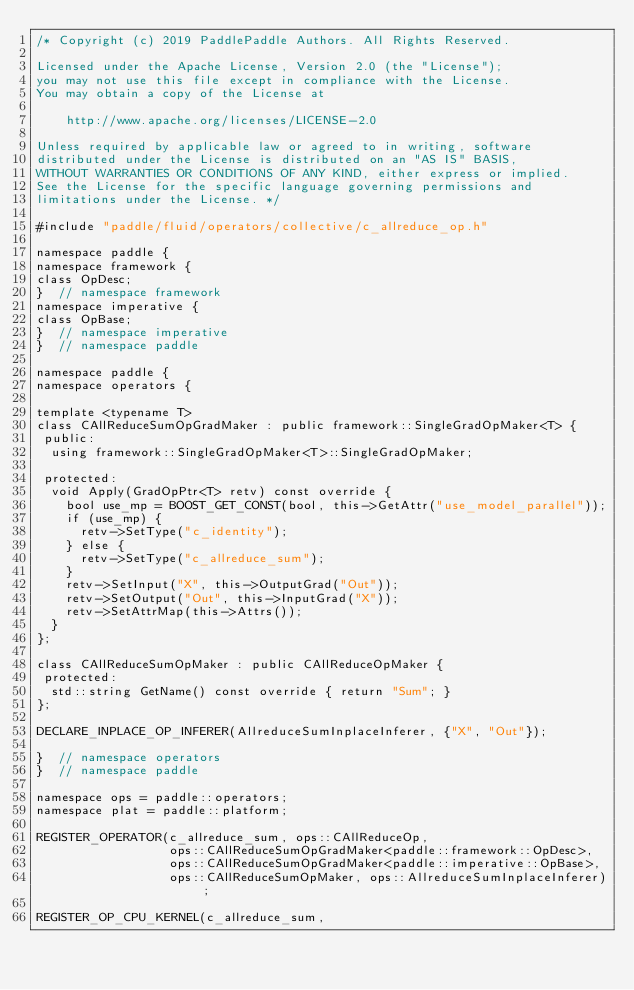<code> <loc_0><loc_0><loc_500><loc_500><_C++_>/* Copyright (c) 2019 PaddlePaddle Authors. All Rights Reserved.

Licensed under the Apache License, Version 2.0 (the "License");
you may not use this file except in compliance with the License.
You may obtain a copy of the License at

    http://www.apache.org/licenses/LICENSE-2.0

Unless required by applicable law or agreed to in writing, software
distributed under the License is distributed on an "AS IS" BASIS,
WITHOUT WARRANTIES OR CONDITIONS OF ANY KIND, either express or implied.
See the License for the specific language governing permissions and
limitations under the License. */

#include "paddle/fluid/operators/collective/c_allreduce_op.h"

namespace paddle {
namespace framework {
class OpDesc;
}  // namespace framework
namespace imperative {
class OpBase;
}  // namespace imperative
}  // namespace paddle

namespace paddle {
namespace operators {

template <typename T>
class CAllReduceSumOpGradMaker : public framework::SingleGradOpMaker<T> {
 public:
  using framework::SingleGradOpMaker<T>::SingleGradOpMaker;

 protected:
  void Apply(GradOpPtr<T> retv) const override {
    bool use_mp = BOOST_GET_CONST(bool, this->GetAttr("use_model_parallel"));
    if (use_mp) {
      retv->SetType("c_identity");
    } else {
      retv->SetType("c_allreduce_sum");
    }
    retv->SetInput("X", this->OutputGrad("Out"));
    retv->SetOutput("Out", this->InputGrad("X"));
    retv->SetAttrMap(this->Attrs());
  }
};

class CAllReduceSumOpMaker : public CAllReduceOpMaker {
 protected:
  std::string GetName() const override { return "Sum"; }
};

DECLARE_INPLACE_OP_INFERER(AllreduceSumInplaceInferer, {"X", "Out"});

}  // namespace operators
}  // namespace paddle

namespace ops = paddle::operators;
namespace plat = paddle::platform;

REGISTER_OPERATOR(c_allreduce_sum, ops::CAllReduceOp,
                  ops::CAllReduceSumOpGradMaker<paddle::framework::OpDesc>,
                  ops::CAllReduceSumOpGradMaker<paddle::imperative::OpBase>,
                  ops::CAllReduceSumOpMaker, ops::AllreduceSumInplaceInferer);

REGISTER_OP_CPU_KERNEL(c_allreduce_sum,</code> 